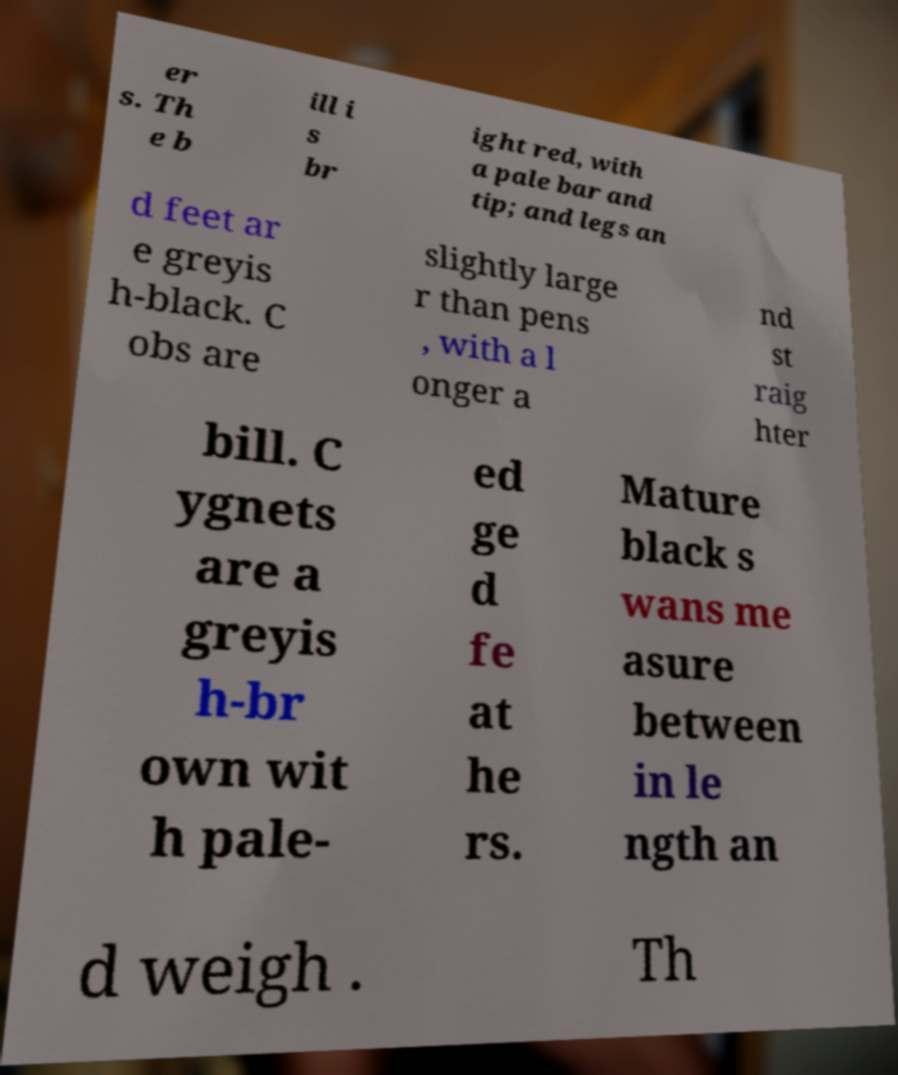Could you extract and type out the text from this image? er s. Th e b ill i s br ight red, with a pale bar and tip; and legs an d feet ar e greyis h-black. C obs are slightly large r than pens , with a l onger a nd st raig hter bill. C ygnets are a greyis h-br own wit h pale- ed ge d fe at he rs. Mature black s wans me asure between in le ngth an d weigh . Th 